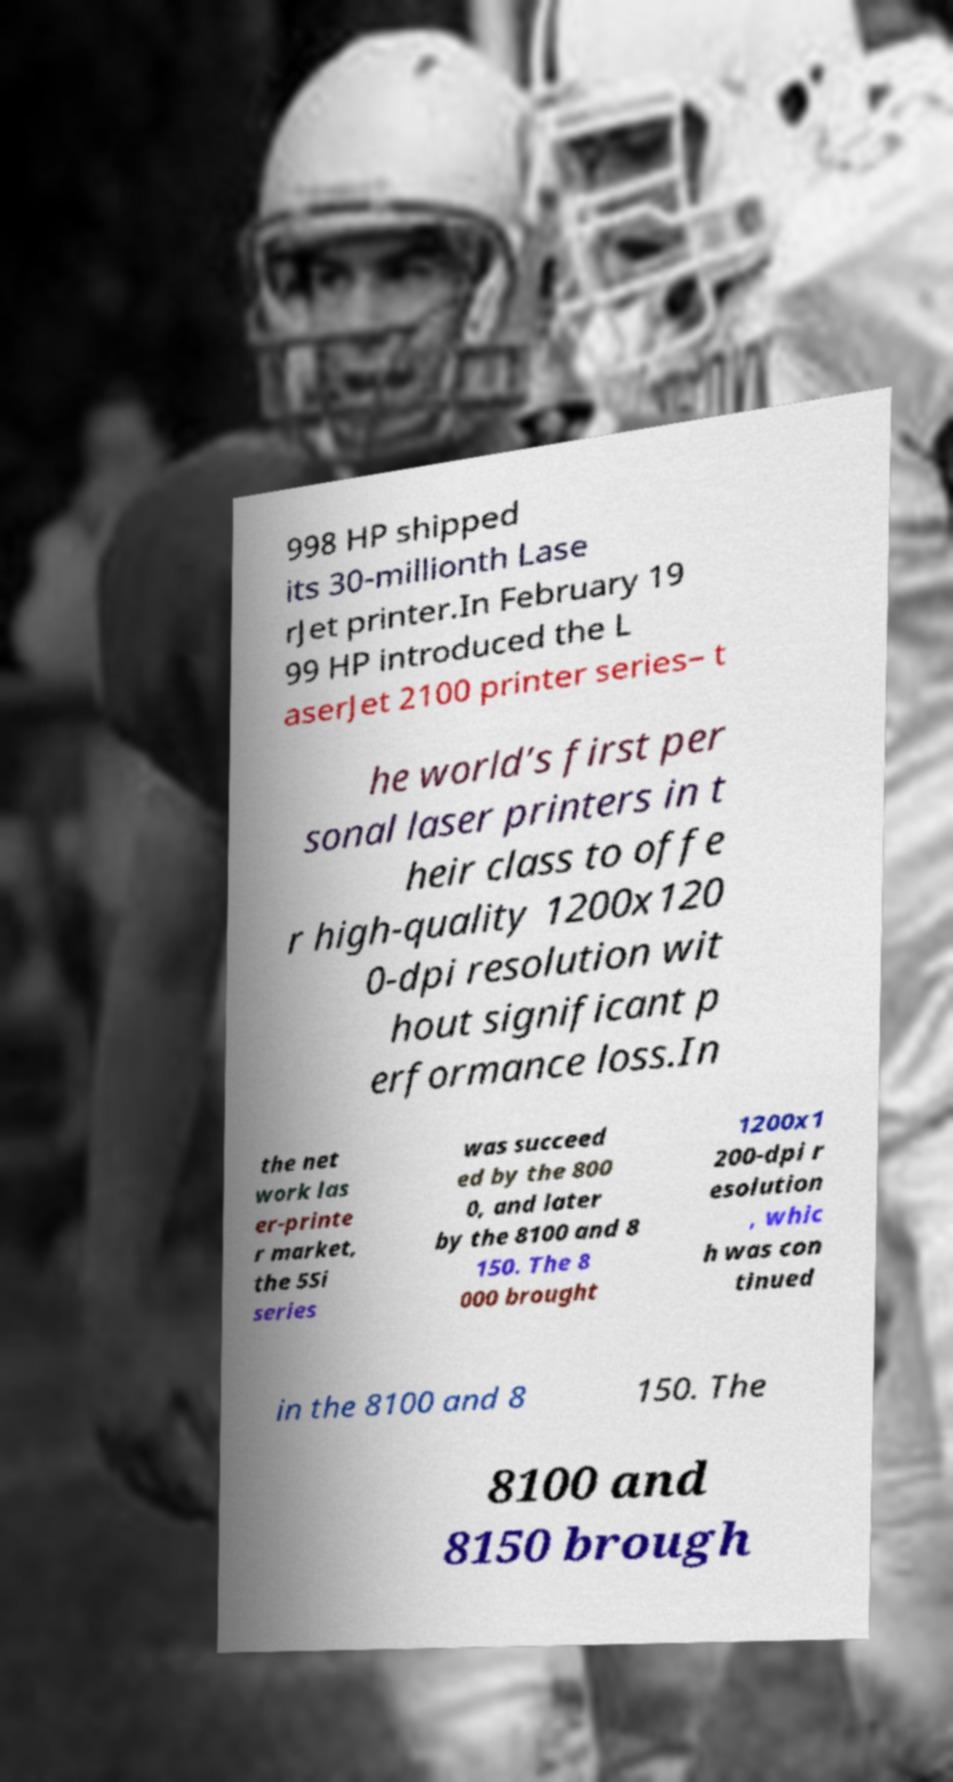There's text embedded in this image that I need extracted. Can you transcribe it verbatim? 998 HP shipped its 30-millionth Lase rJet printer.In February 19 99 HP introduced the L aserJet 2100 printer series– t he world’s first per sonal laser printers in t heir class to offe r high-quality 1200x120 0-dpi resolution wit hout significant p erformance loss.In the net work las er-printe r market, the 5Si series was succeed ed by the 800 0, and later by the 8100 and 8 150. The 8 000 brought 1200x1 200-dpi r esolution , whic h was con tinued in the 8100 and 8 150. The 8100 and 8150 brough 